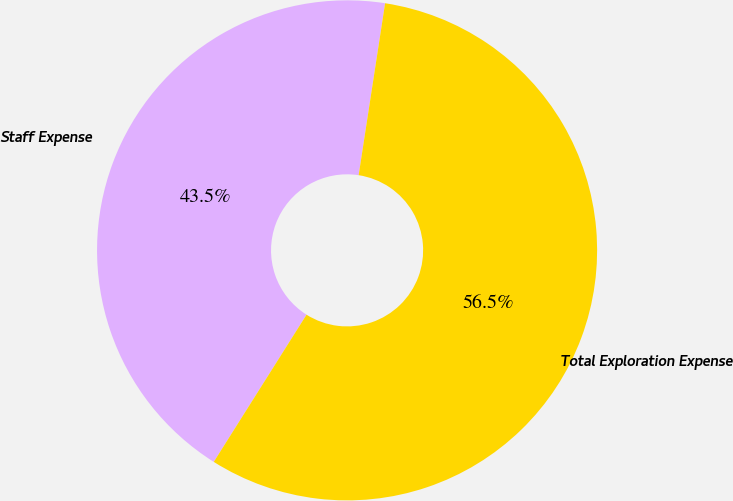<chart> <loc_0><loc_0><loc_500><loc_500><pie_chart><fcel>Staff Expense<fcel>Total Exploration Expense<nl><fcel>43.48%<fcel>56.52%<nl></chart> 